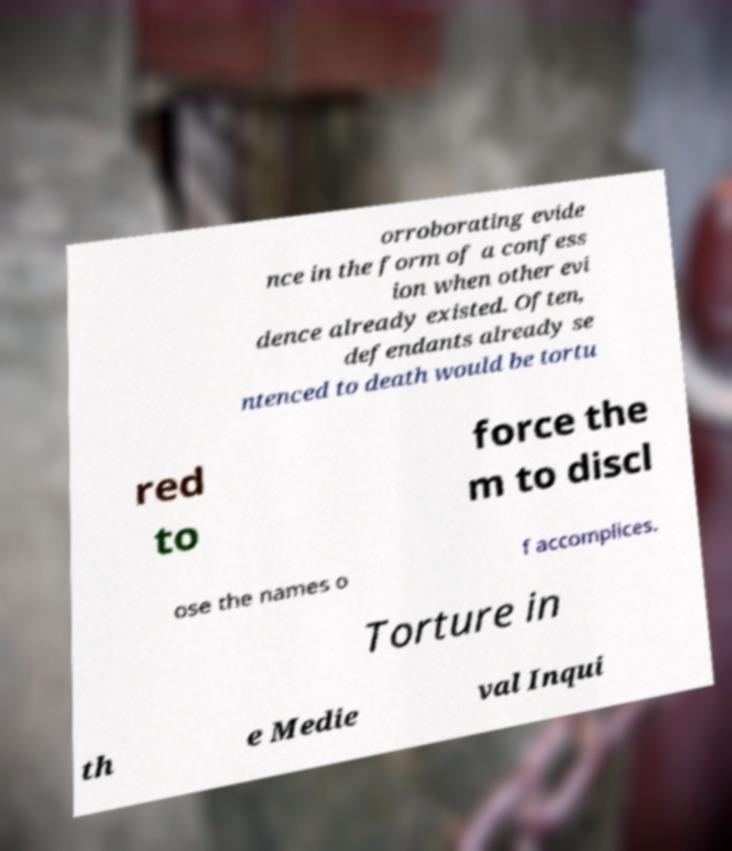Could you extract and type out the text from this image? orroborating evide nce in the form of a confess ion when other evi dence already existed. Often, defendants already se ntenced to death would be tortu red to force the m to discl ose the names o f accomplices. Torture in th e Medie val Inqui 